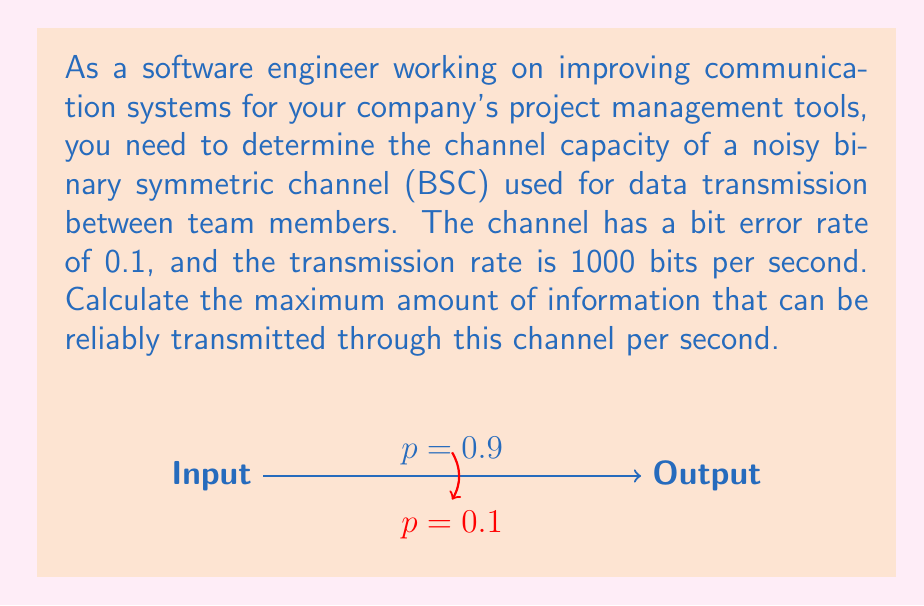Teach me how to tackle this problem. To solve this problem, we'll use the Shannon-Hartley theorem and the properties of a binary symmetric channel (BSC). Let's break it down step-by-step:

1) For a BSC, the channel capacity is given by:
   $$C = 1 - H(p)$$
   where $C$ is the capacity in bits per channel use, and $H(p)$ is the binary entropy function.

2) The binary entropy function is defined as:
   $$H(p) = -p \log_2(p) - (1-p) \log_2(1-p)$$
   where $p$ is the probability of error (bit error rate).

3) Given: 
   - Bit error rate $p = 0.1$
   - Transmission rate = 1000 bits per second

4) Let's calculate $H(p)$:
   $$\begin{align*}
   H(0.1) &= -0.1 \log_2(0.1) - 0.9 \log_2(0.9) \\
   &\approx 0.1 \cdot 3.32 + 0.9 \cdot 0.15 \\
   &\approx 0.332 + 0.135 \\
   &\approx 0.467
   \end{align*}$$

5) Now we can calculate the capacity per channel use:
   $$\begin{align*}
   C &= 1 - H(p) \\
   &= 1 - 0.467 \\
   &\approx 0.533 \text{ bits per channel use}
   \end{align*}$$

6) To get the capacity in bits per second, we multiply by the transmission rate:
   $$\begin{align*}
   C_{bps} &= 0.533 \cdot 1000 \\
   &= 533 \text{ bits per second}
   \end{align*}$$

Therefore, the maximum amount of information that can be reliably transmitted through this channel is approximately 533 bits per second.
Answer: 533 bits per second 